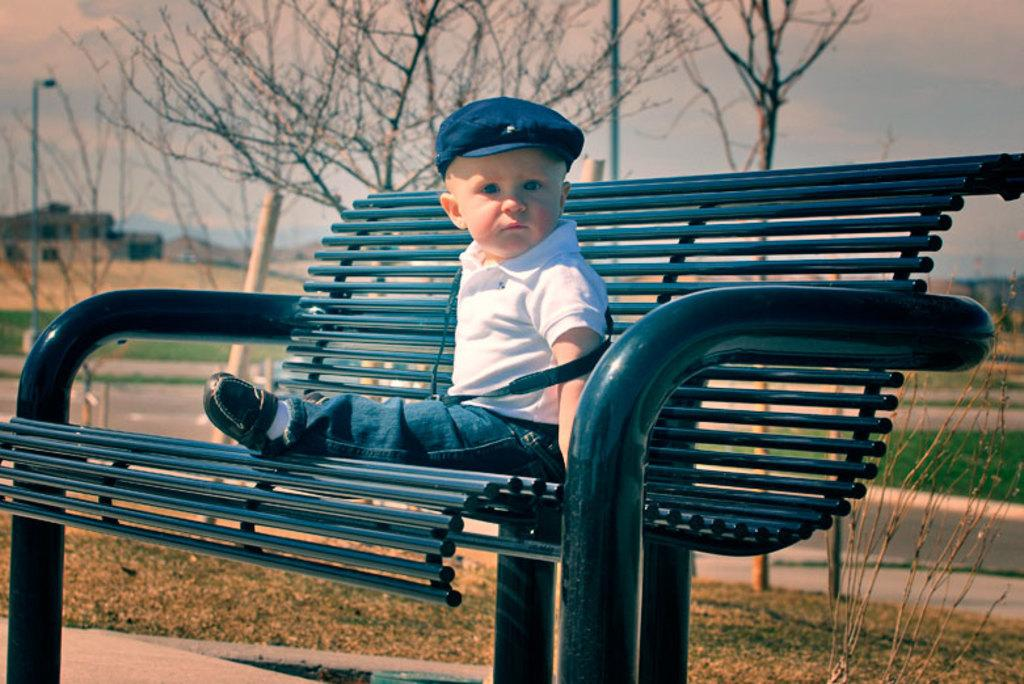What is the main subject of the image? There is a child in the image. What is the child doing in the image? The child is sitting on a bench. What can be seen in the background of the image? There are trees and a building in the background of the image. What type of jewel is the child wearing in the image? There is no mention of a jewel in the image, so it cannot be determined if the child is wearing one. 